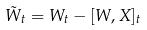<formula> <loc_0><loc_0><loc_500><loc_500>\tilde { W } _ { t } = W _ { t } - [ W , X ] _ { t }</formula> 